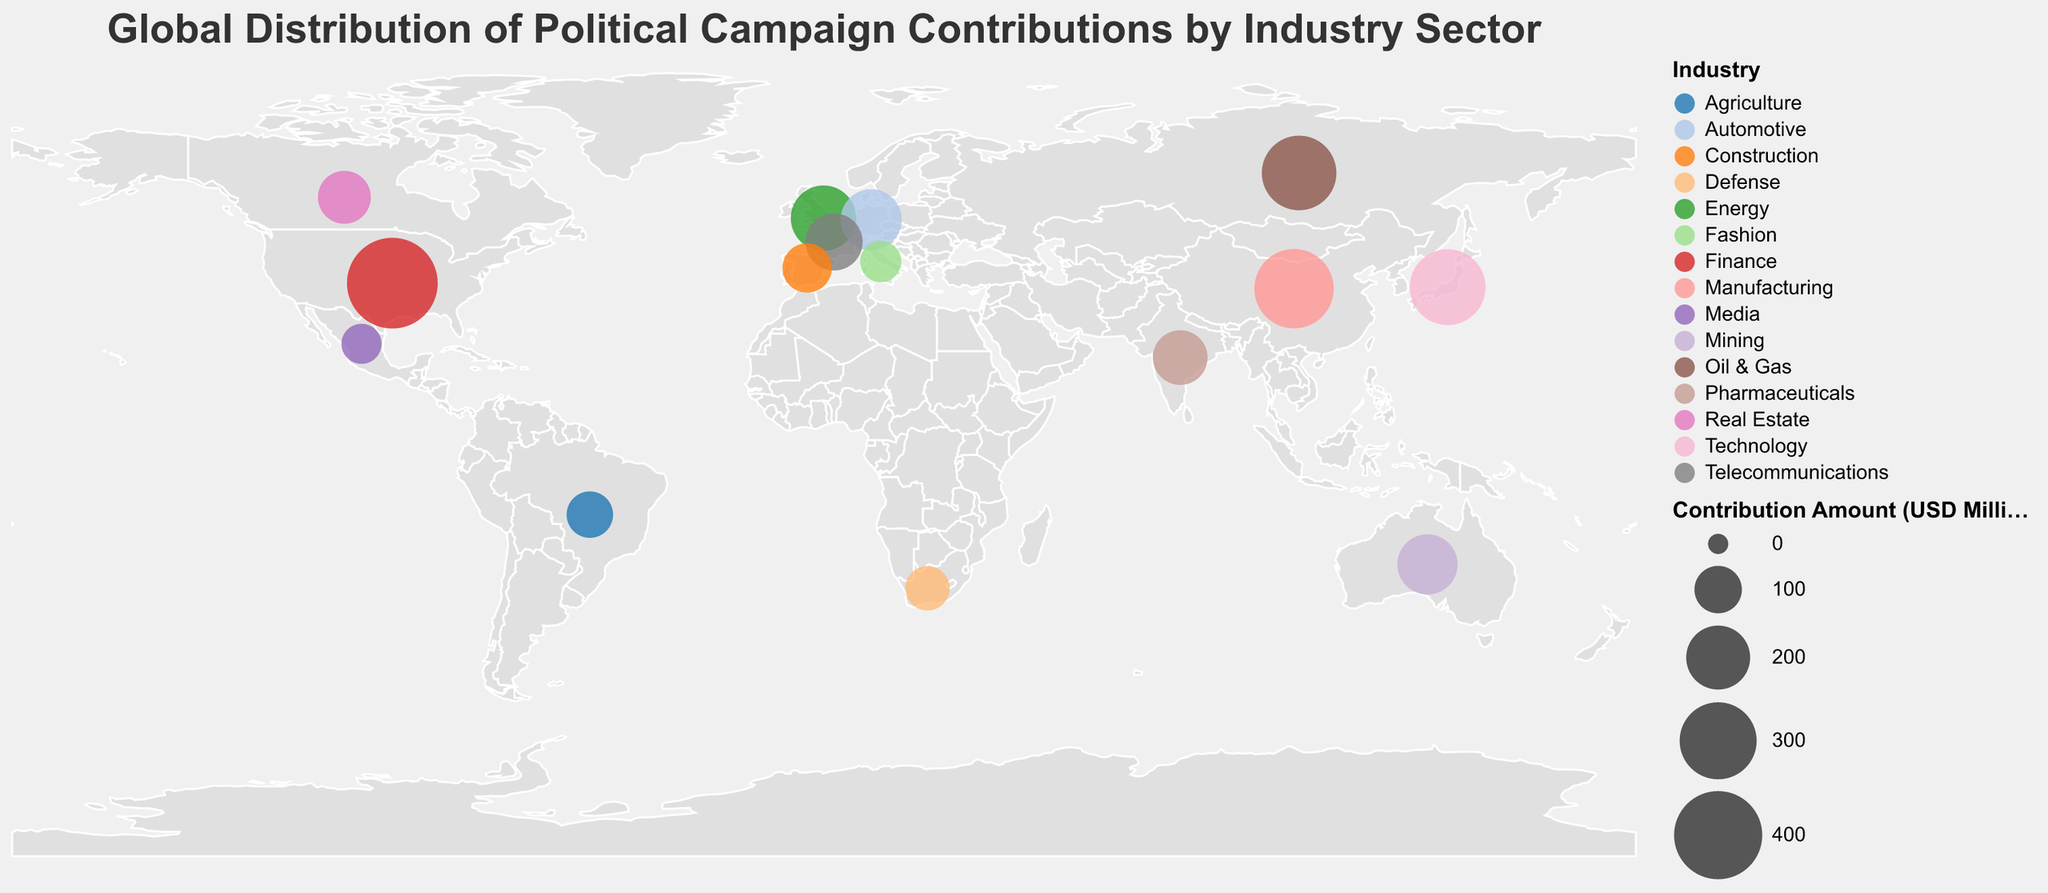What is the total political campaign contribution amount for Asian countries on the plot? To find the total political campaign contribution amount for Asian countries, we need to identify the Asian countries in the plot and sum their contributions. The countries included are Japan, China, India, and Russia. Their contributions are 290, 320, 140, and 280 million USD, respectively. Adding them together: 290 + 320 + 140 + 280 = 1030 million USD
Answer: 1030 million USD Which country has the highest political campaign contribution amount, and which industry is it from? Observing the circle sizes on the plot and the tooltip information, the United States has the highest contribution amount at 425 million USD, attributed to the Finance industry
Answer: United States, Finance How does the contribution of the Manufacturing sector in China compare to that of the Technology sector in Japan? According to the plot, China's Manufacturing sector contributes 320 million USD, while Japan's Technology sector contributes 290 million USD. Comparing these amounts, the Manufacturing sector in China contributes more by 30 million USD
Answer: Manufacturing sector in China contributes 30 million USD more 